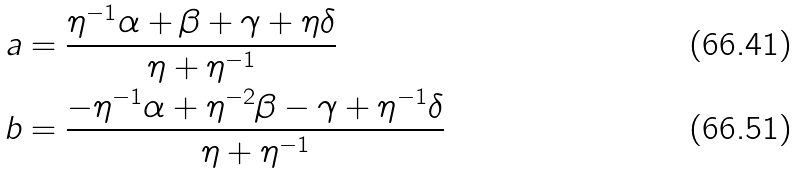<formula> <loc_0><loc_0><loc_500><loc_500>a & = \frac { \eta ^ { - 1 } \alpha + \beta + \gamma + \eta \delta } { \eta + \eta ^ { - 1 } } \\ b & = \frac { - \eta ^ { - 1 } \alpha + \eta ^ { - 2 } \beta - \gamma + \eta ^ { - 1 } \delta } { \eta + \eta ^ { - 1 } }</formula> 